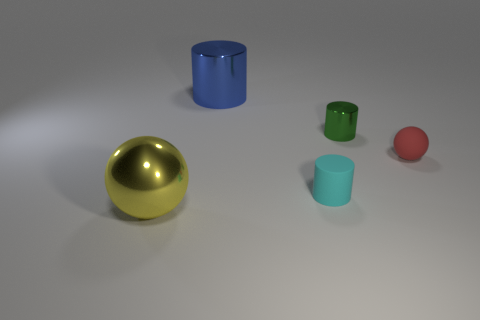Subtract all rubber cylinders. How many cylinders are left? 2 Add 1 large gray metal blocks. How many objects exist? 6 Subtract all cylinders. How many objects are left? 2 Subtract all big yellow matte objects. Subtract all big blue shiny cylinders. How many objects are left? 4 Add 3 big shiny cylinders. How many big shiny cylinders are left? 4 Add 3 big red metallic balls. How many big red metallic balls exist? 3 Subtract 0 yellow cylinders. How many objects are left? 5 